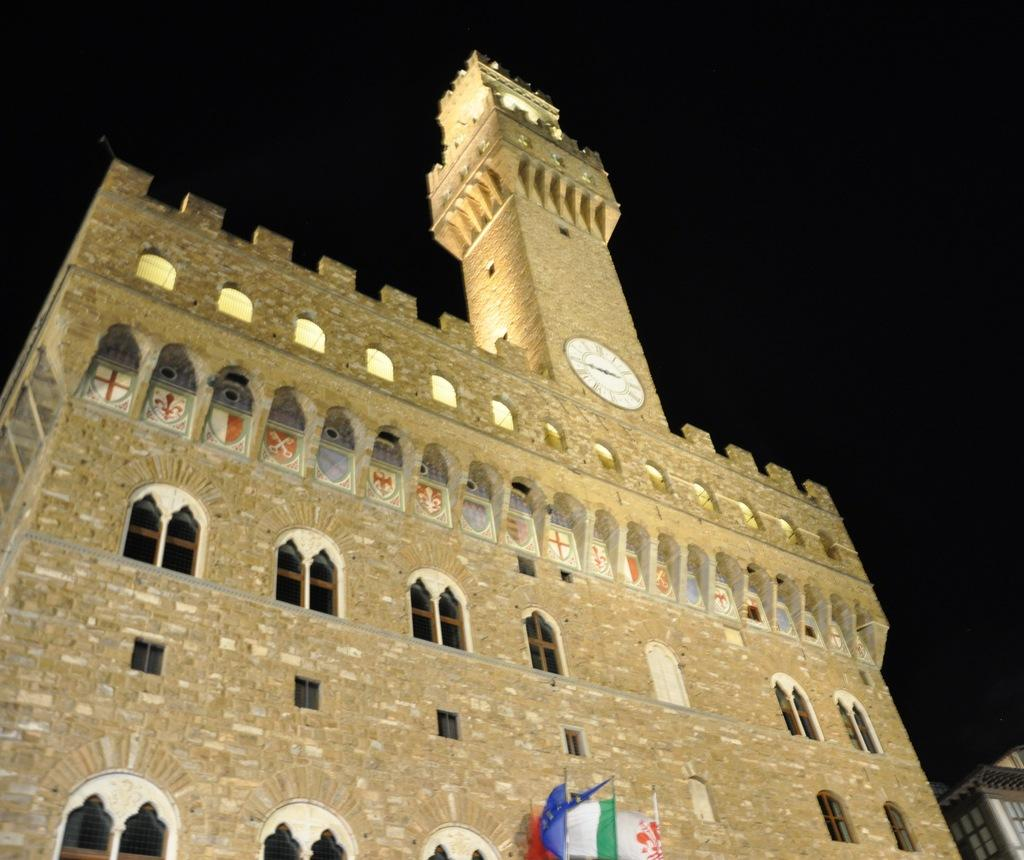What type of structures are visible in the image? There are buildings in the image. What feature can be seen on the buildings? There are windows on the buildings. What time-related object is present in the image? There is a clock in the image. What type of decorative elements are visible in the image? There are flags in the image. How would you describe the lighting in the image? The sky is dark in the image. Can you see the rhythm of the volleyball game in the image? There is no volleyball game present in the image, so it is not possible to see the rhythm of a game. 